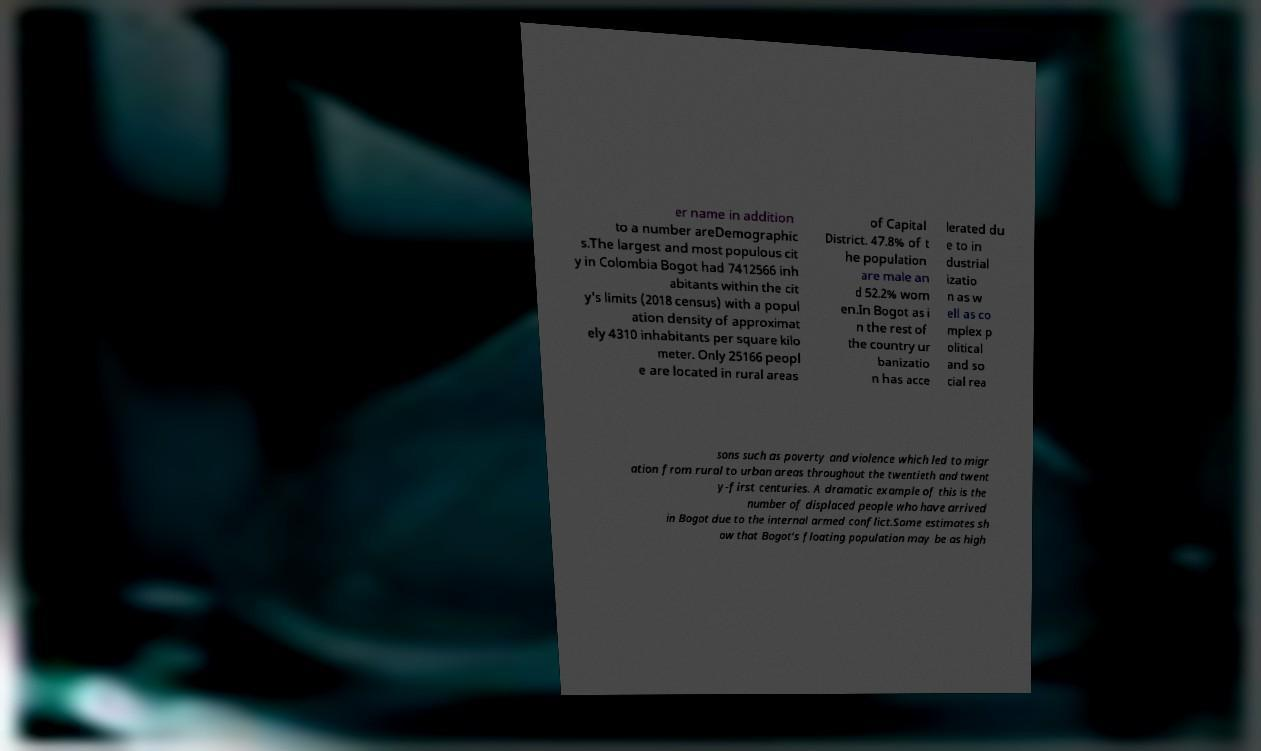Please read and relay the text visible in this image. What does it say? er name in addition to a number areDemographic s.The largest and most populous cit y in Colombia Bogot had 7412566 inh abitants within the cit y's limits (2018 census) with a popul ation density of approximat ely 4310 inhabitants per square kilo meter. Only 25166 peopl e are located in rural areas of Capital District. 47.8% of t he population are male an d 52.2% wom en.In Bogot as i n the rest of the country ur banizatio n has acce lerated du e to in dustrial izatio n as w ell as co mplex p olitical and so cial rea sons such as poverty and violence which led to migr ation from rural to urban areas throughout the twentieth and twent y-first centuries. A dramatic example of this is the number of displaced people who have arrived in Bogot due to the internal armed conflict.Some estimates sh ow that Bogot's floating population may be as high 